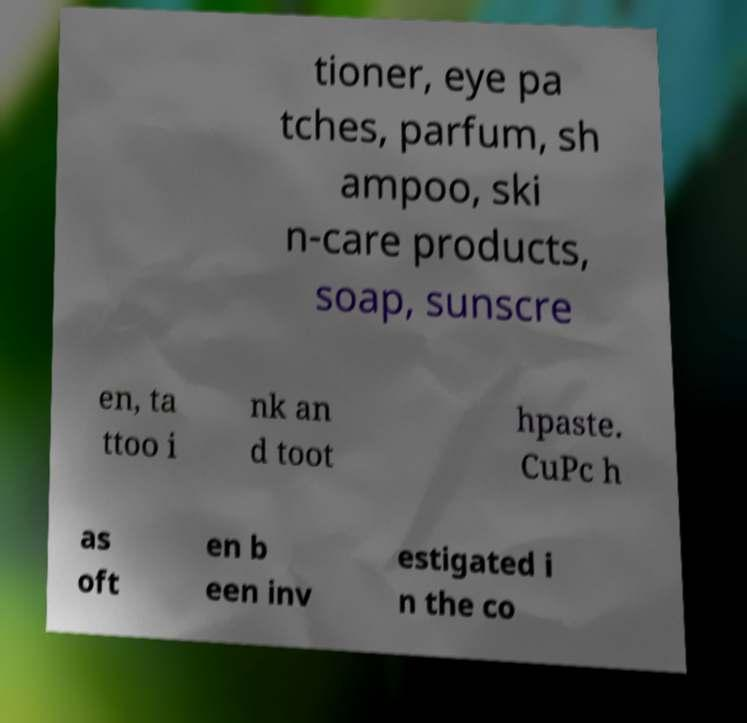Could you assist in decoding the text presented in this image and type it out clearly? tioner, eye pa tches, parfum, sh ampoo, ski n-care products, soap, sunscre en, ta ttoo i nk an d toot hpaste. CuPc h as oft en b een inv estigated i n the co 